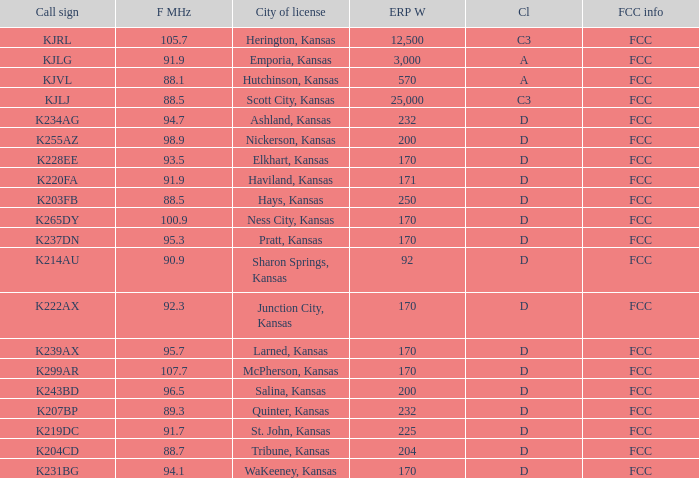Parse the full table. {'header': ['Call sign', 'F MHz', 'City of license', 'ERP W', 'Cl', 'FCC info'], 'rows': [['KJRL', '105.7', 'Herington, Kansas', '12,500', 'C3', 'FCC'], ['KJLG', '91.9', 'Emporia, Kansas', '3,000', 'A', 'FCC'], ['KJVL', '88.1', 'Hutchinson, Kansas', '570', 'A', 'FCC'], ['KJLJ', '88.5', 'Scott City, Kansas', '25,000', 'C3', 'FCC'], ['K234AG', '94.7', 'Ashland, Kansas', '232', 'D', 'FCC'], ['K255AZ', '98.9', 'Nickerson, Kansas', '200', 'D', 'FCC'], ['K228EE', '93.5', 'Elkhart, Kansas', '170', 'D', 'FCC'], ['K220FA', '91.9', 'Haviland, Kansas', '171', 'D', 'FCC'], ['K203FB', '88.5', 'Hays, Kansas', '250', 'D', 'FCC'], ['K265DY', '100.9', 'Ness City, Kansas', '170', 'D', 'FCC'], ['K237DN', '95.3', 'Pratt, Kansas', '170', 'D', 'FCC'], ['K214AU', '90.9', 'Sharon Springs, Kansas', '92', 'D', 'FCC'], ['K222AX', '92.3', 'Junction City, Kansas', '170', 'D', 'FCC'], ['K239AX', '95.7', 'Larned, Kansas', '170', 'D', 'FCC'], ['K299AR', '107.7', 'McPherson, Kansas', '170', 'D', 'FCC'], ['K243BD', '96.5', 'Salina, Kansas', '200', 'D', 'FCC'], ['K207BP', '89.3', 'Quinter, Kansas', '232', 'D', 'FCC'], ['K219DC', '91.7', 'St. John, Kansas', '225', 'D', 'FCC'], ['K204CD', '88.7', 'Tribune, Kansas', '204', 'D', 'FCC'], ['K231BG', '94.1', 'WaKeeney, Kansas', '170', 'D', 'FCC']]} Call sign of k231bg has what sum of erp w? 170.0. 